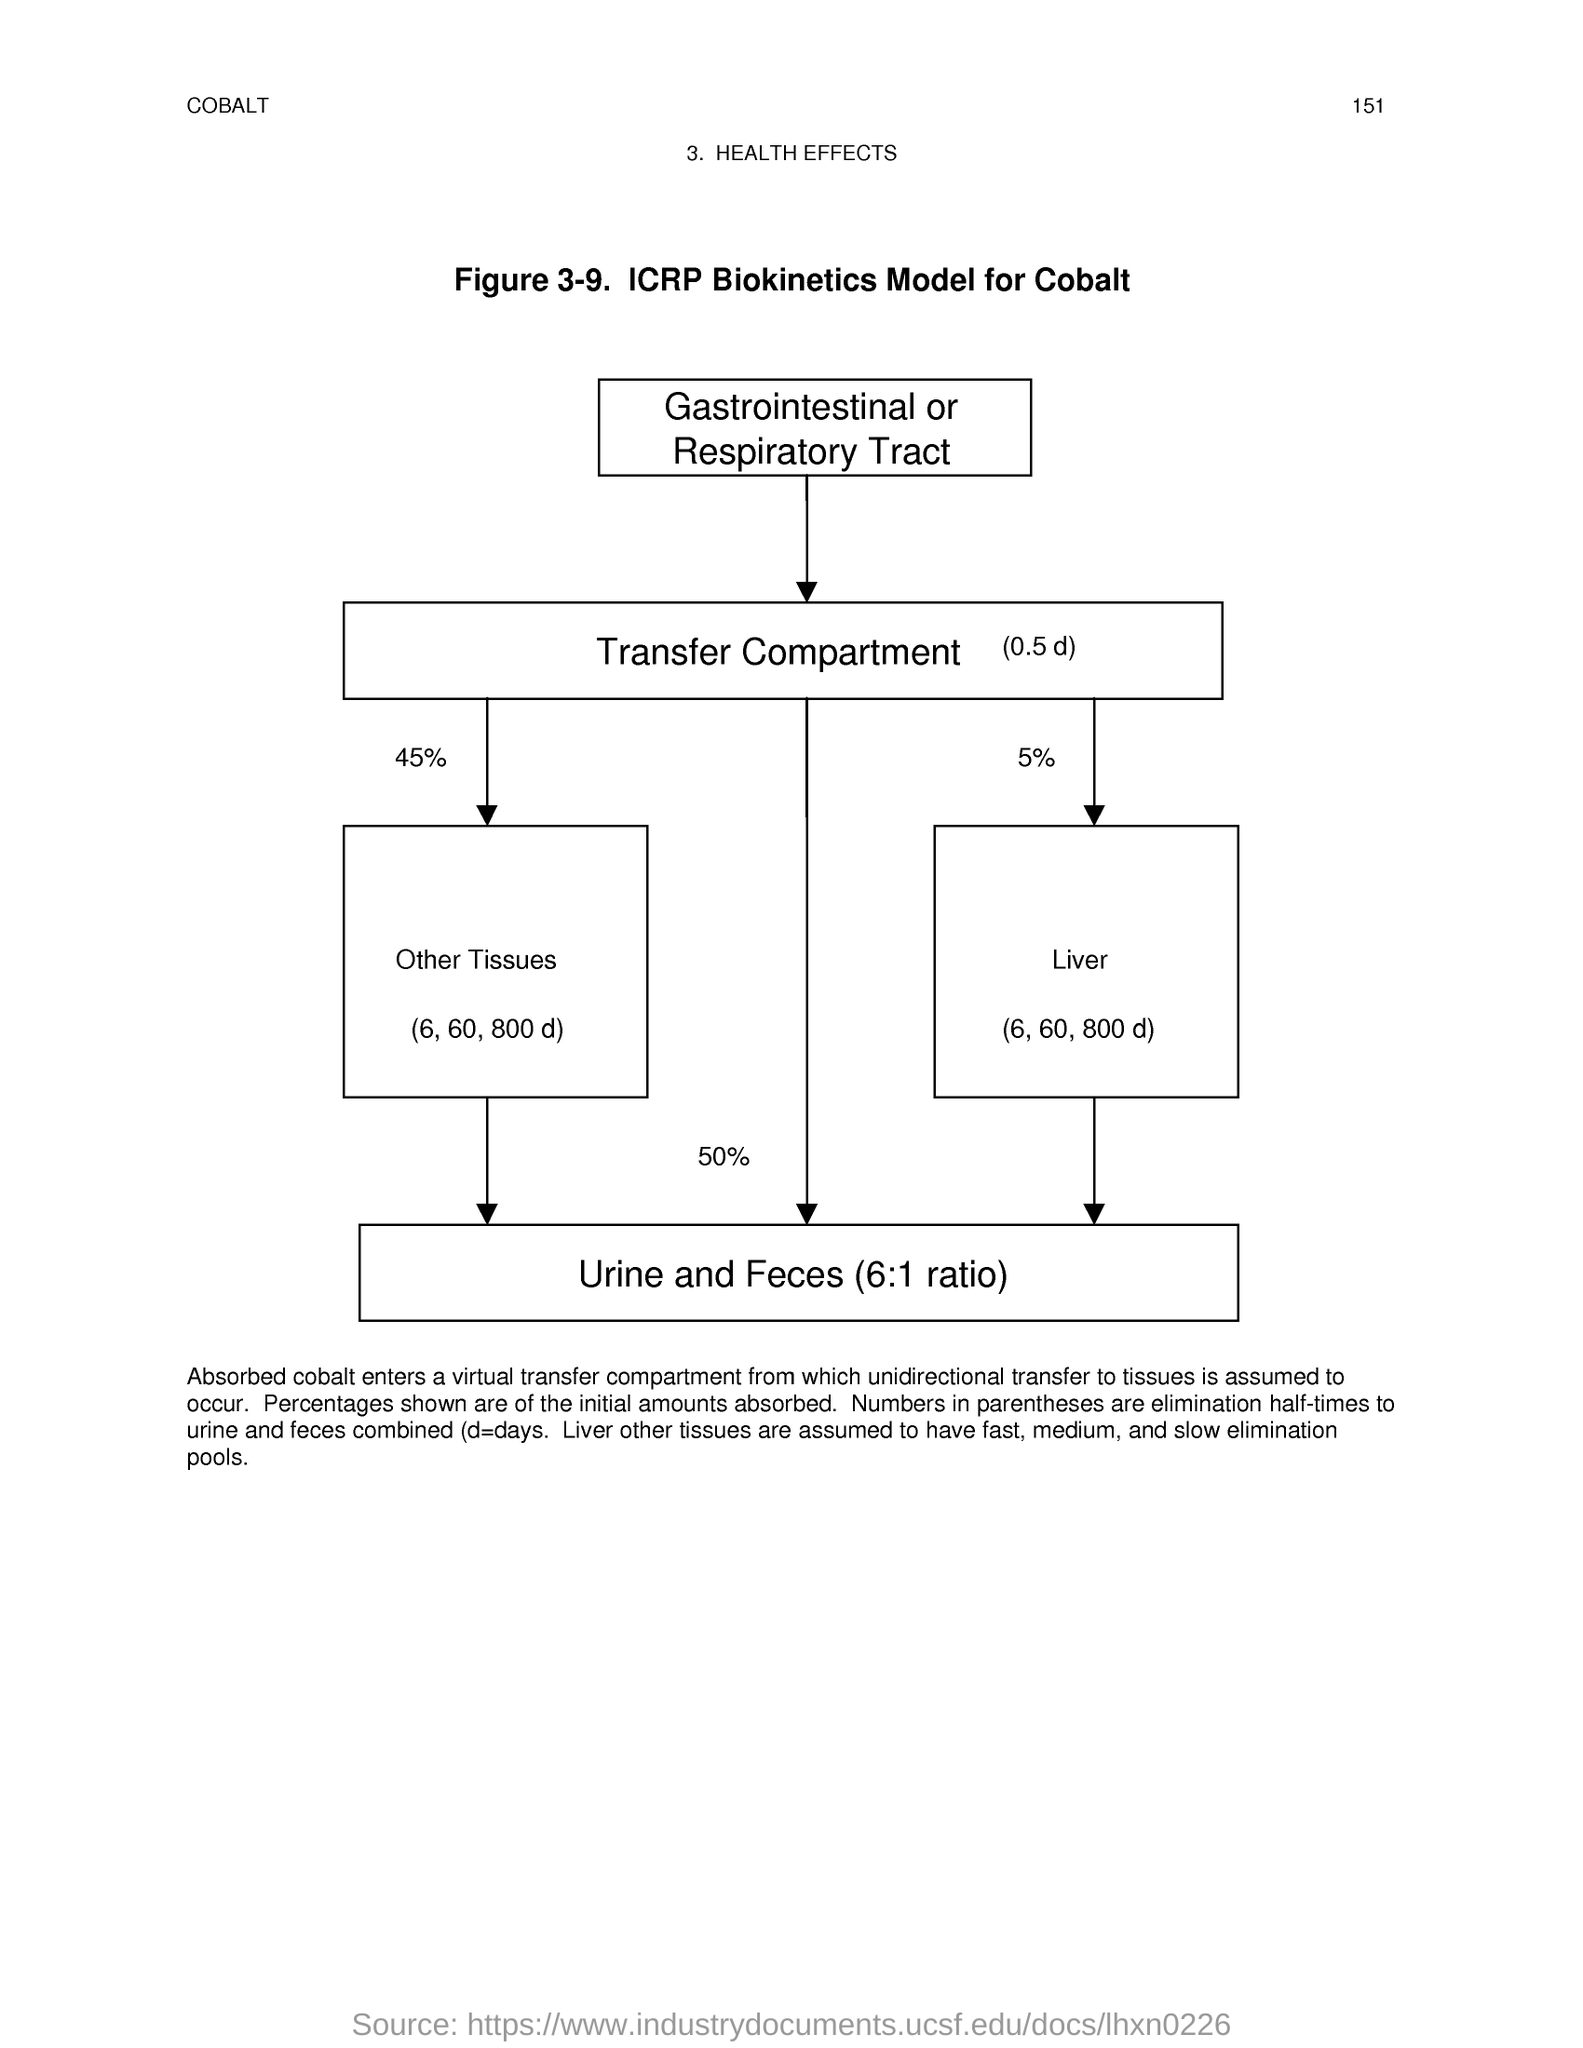What is the ratio of Urine and Feces?
Your response must be concise. 6:1 ratio. What is the Page Number?
Your response must be concise. 151. 